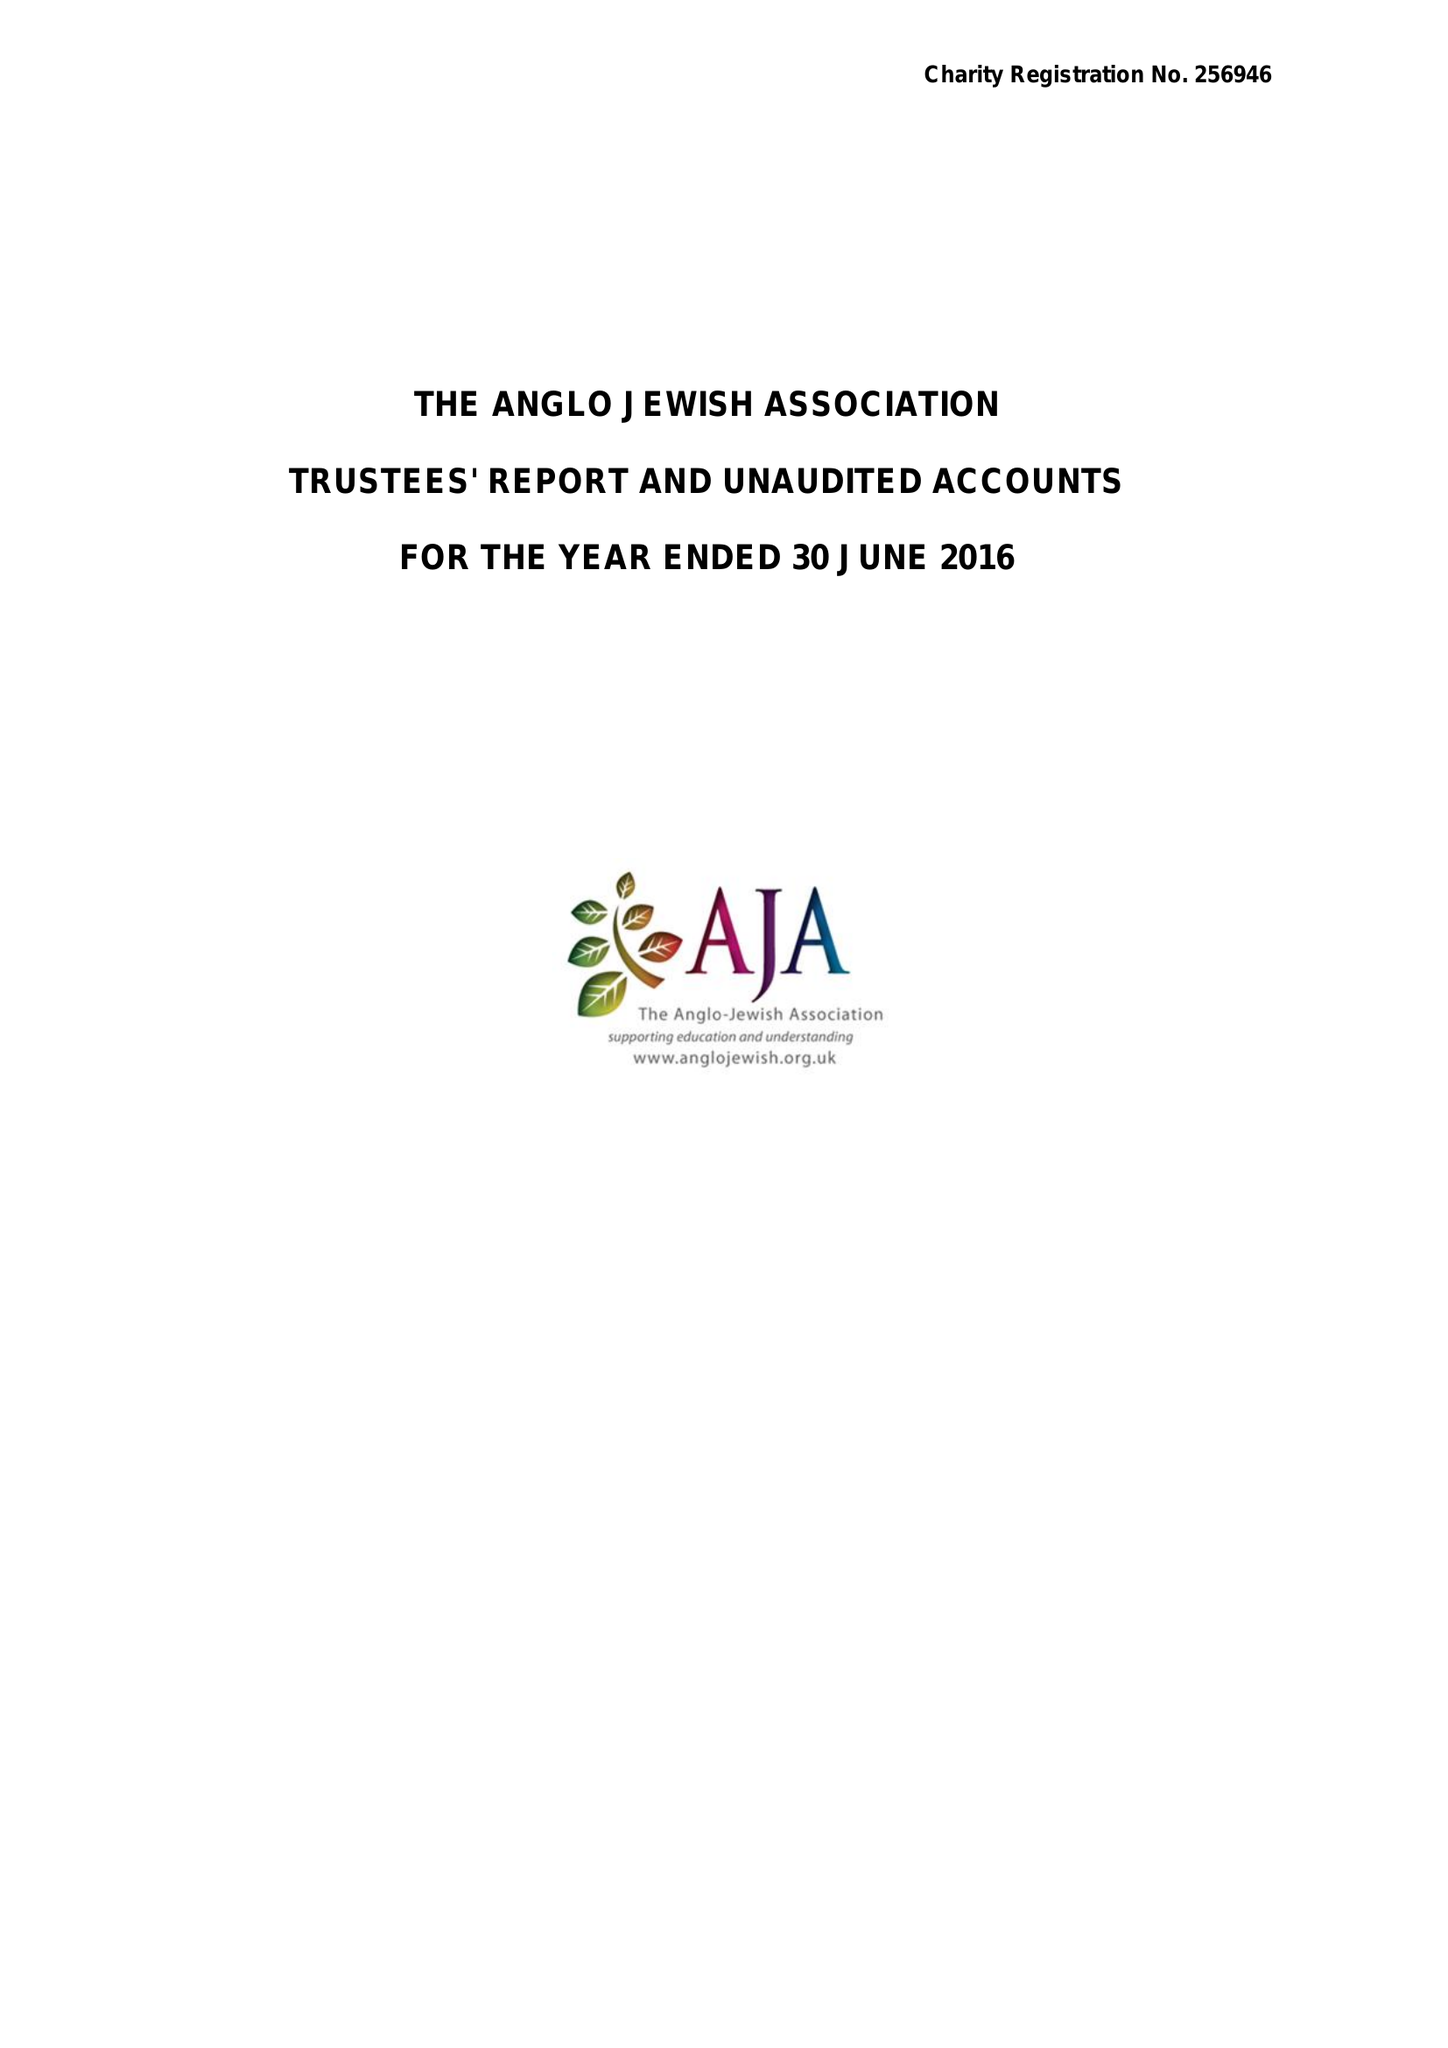What is the value for the address__postcode?
Answer the question using a single word or phrase. NW6 2EG 